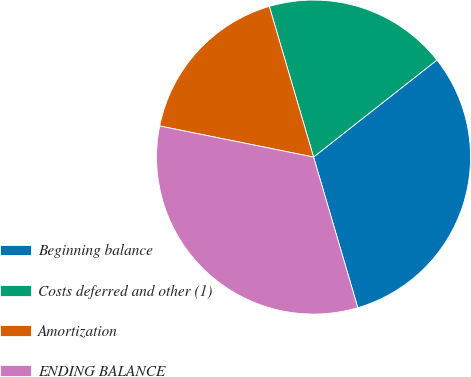Convert chart. <chart><loc_0><loc_0><loc_500><loc_500><pie_chart><fcel>Beginning balance<fcel>Costs deferred and other (1)<fcel>Amortization<fcel>ENDING BALANCE<nl><fcel>31.06%<fcel>18.94%<fcel>17.28%<fcel>32.72%<nl></chart> 